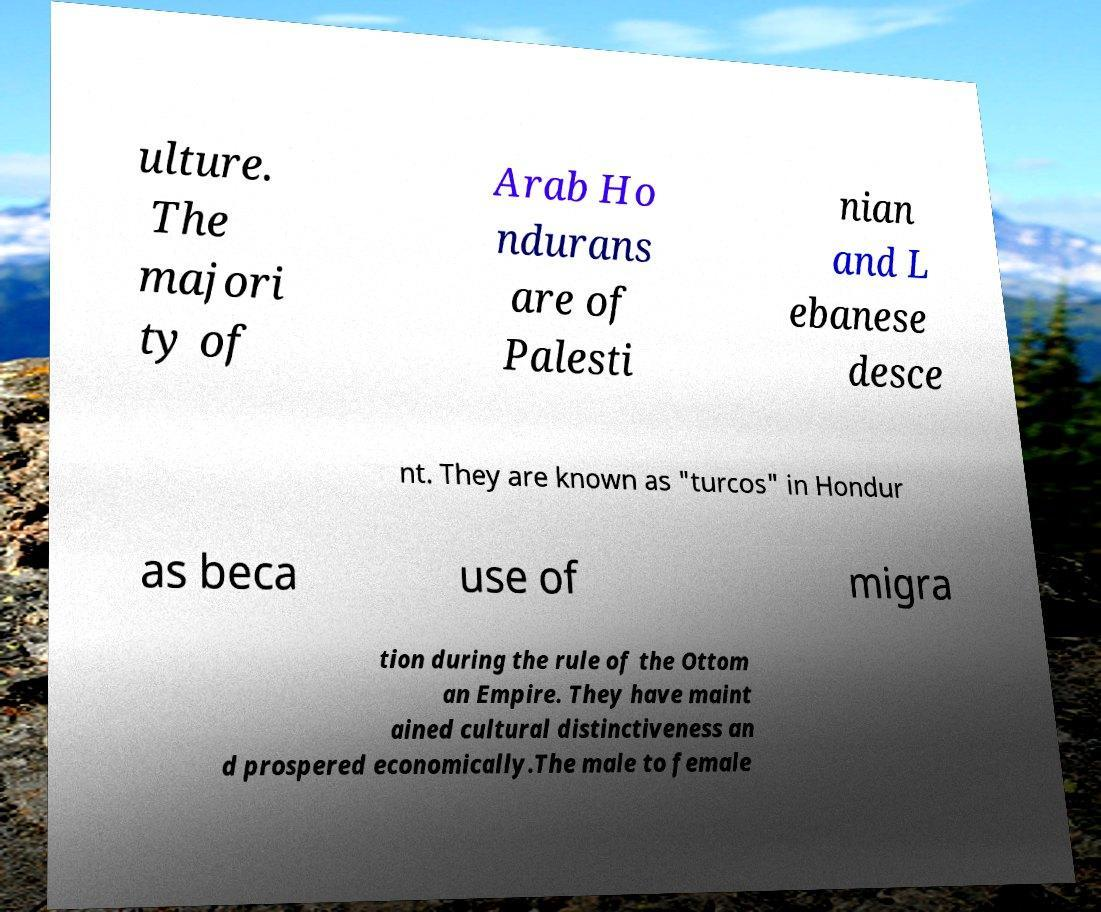There's text embedded in this image that I need extracted. Can you transcribe it verbatim? ulture. The majori ty of Arab Ho ndurans are of Palesti nian and L ebanese desce nt. They are known as "turcos" in Hondur as beca use of migra tion during the rule of the Ottom an Empire. They have maint ained cultural distinctiveness an d prospered economically.The male to female 